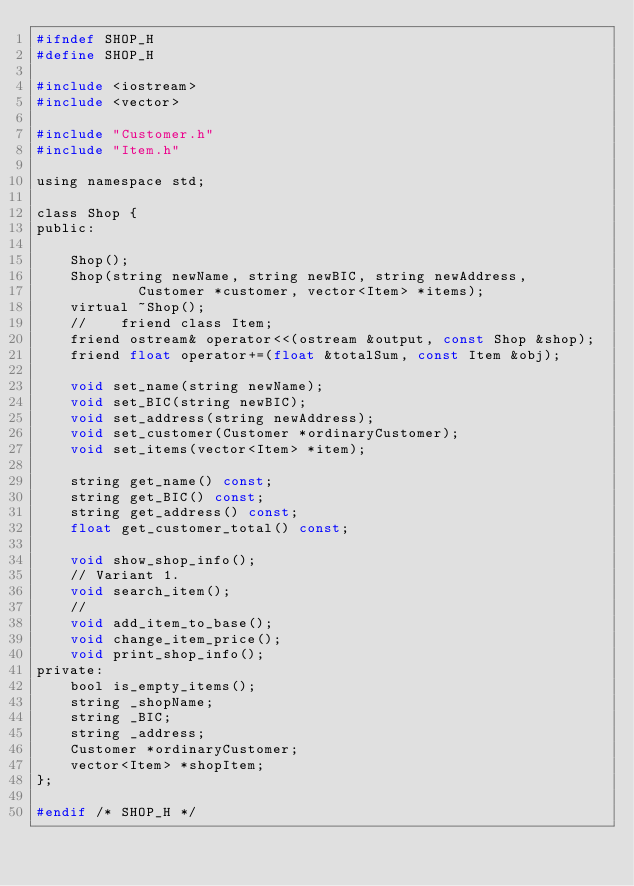Convert code to text. <code><loc_0><loc_0><loc_500><loc_500><_C_>#ifndef SHOP_H
#define SHOP_H

#include <iostream>
#include <vector>

#include "Customer.h"
#include "Item.h"

using namespace std;

class Shop {
public:

    Shop();
    Shop(string newName, string newBIC, string newAddress,
            Customer *customer, vector<Item> *items);
    virtual ~Shop();
    //    friend class Item;
    friend ostream& operator<<(ostream &output, const Shop &shop);
    friend float operator+=(float &totalSum, const Item &obj);

    void set_name(string newName);
    void set_BIC(string newBIC);
    void set_address(string newAddress);
    void set_customer(Customer *ordinaryCustomer);
    void set_items(vector<Item> *item);

    string get_name() const;
    string get_BIC() const;
    string get_address() const;
    float get_customer_total() const;

    void show_shop_info();
    // Variant 1.
    void search_item();
    //
    void add_item_to_base();
    void change_item_price();
    void print_shop_info();
private:
    bool is_empty_items();
    string _shopName;
    string _BIC;
    string _address;
    Customer *ordinaryCustomer;
    vector<Item> *shopItem;
};

#endif /* SHOP_H */

</code> 